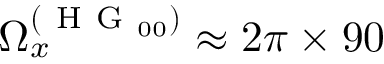<formula> <loc_0><loc_0><loc_500><loc_500>\Omega _ { x } ^ { ( H G _ { 0 0 } ) } \approx 2 \pi \times 9 0</formula> 